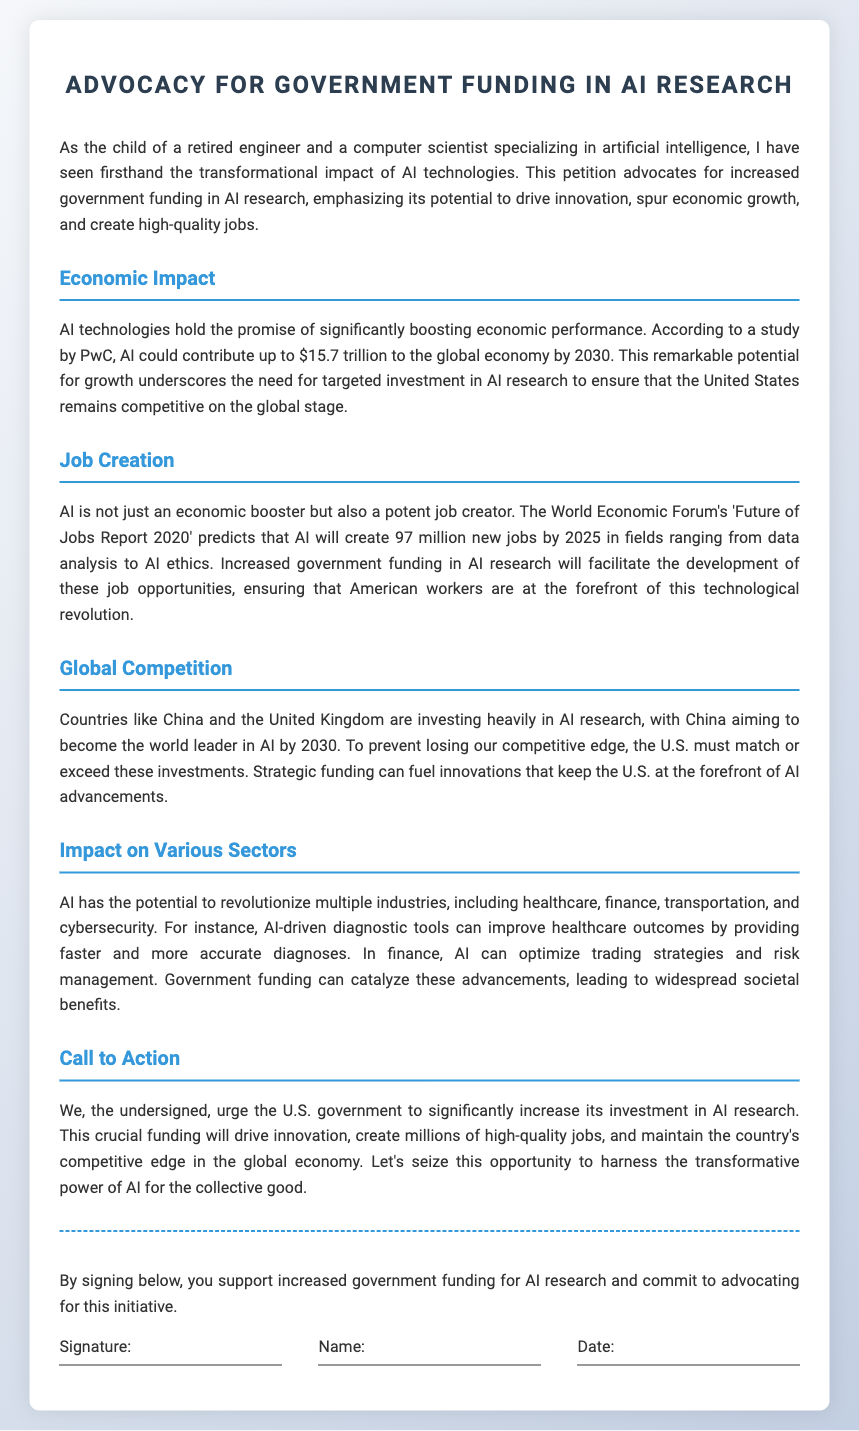what is the title of the petition? The title of the petition is stated at the top of the document.
Answer: Advocacy for Government Funding in AI Research how much could AI contribute to the global economy by 2030? This information is found in the Economic Impact section, where it discusses potential economic contributions.
Answer: $15.7 trillion how many new jobs will AI create by 2025 according to the report? This number can be found in the Job Creation section that references the World Economic Forum's report.
Answer: 97 million which countries are mentioned as investing heavily in AI research? The document notes countries that are competing in AI research investment.
Answer: China and the United Kingdom what is the main call to action in the petition? This is summarized in the Call to Action section, capturing the essence of what the petition aims to achieve.
Answer: Increase investment in AI research what sector is mentioned as having AI potential for improving healthcare outcomes? A specific industry where AI can make significant improvements is noted in the Impact on Various Sectors section.
Answer: Healthcare who is urged to increase investment in AI research? The document indicates who the petition is addressing for action.
Answer: U.S. government what is mentioned as a reason for the U.S. to increase funding in AI? The rationale provided relates to global competition and maintaining a competitive edge.
Answer: Prevent losing competitive edge 